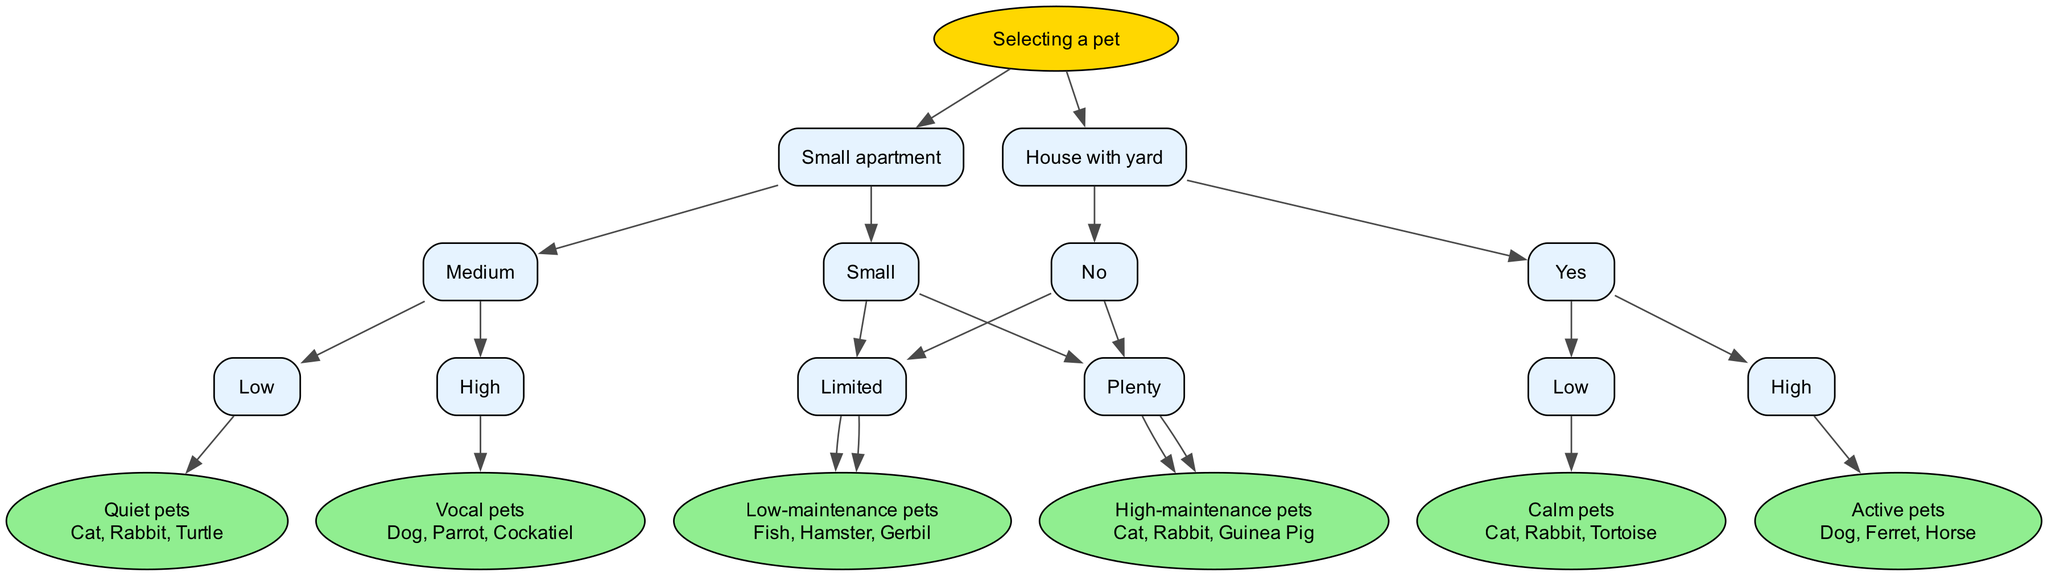What is the first question in the decision tree? The first question posed in the decision tree is at the root node, which asks about the living space available for the pet.
Answer: Living space? What type of pet is suggested if you have a small apartment and limited time for care? Starting with a small apartment, we follow its branch to the next node which asks about pet size. If limited time for care is chosen, it directs us to the leaf node that suggests low-maintenance pets.
Answer: Low-maintenance pets What are the examples given for high-maintenance pets? After following the nodes for a house with a yard and having plenty of time for care, the leaf node for high-maintenance pets lists specific examples. Thus, the pets are detailed in this node as: Cat, Rabbit, Guinea Pig.
Answer: Cat, Rabbit, Guinea Pig How many leaf nodes are present in this decision tree? By reviewing the structure of the decision tree, we count the leaf nodes which conclude each path from questions, resulting in a total of six leaf nodes present in the diagram.
Answer: 6 If someone has a house with a yard and a high noise tolerance, what type of pets can they consider? Starting with a house with a yard leads to the outdoor access question. Assuming high noise tolerance leads to vocal pets, hence this path identifies possible pet types such as dogs, parrots, and cockatiels.
Answer: Vocal pets What is the outcome for someone living in a small apartment with high noise tolerance? Beginning with a small apartment forces a move to the pet size question. Given high noise tolerance, it proceeds to vocal pets after navigating through noise tolerance questions. This denotes a preference for pets that may be louder, such as dogs or parrots.
Answer: Vocal pets 